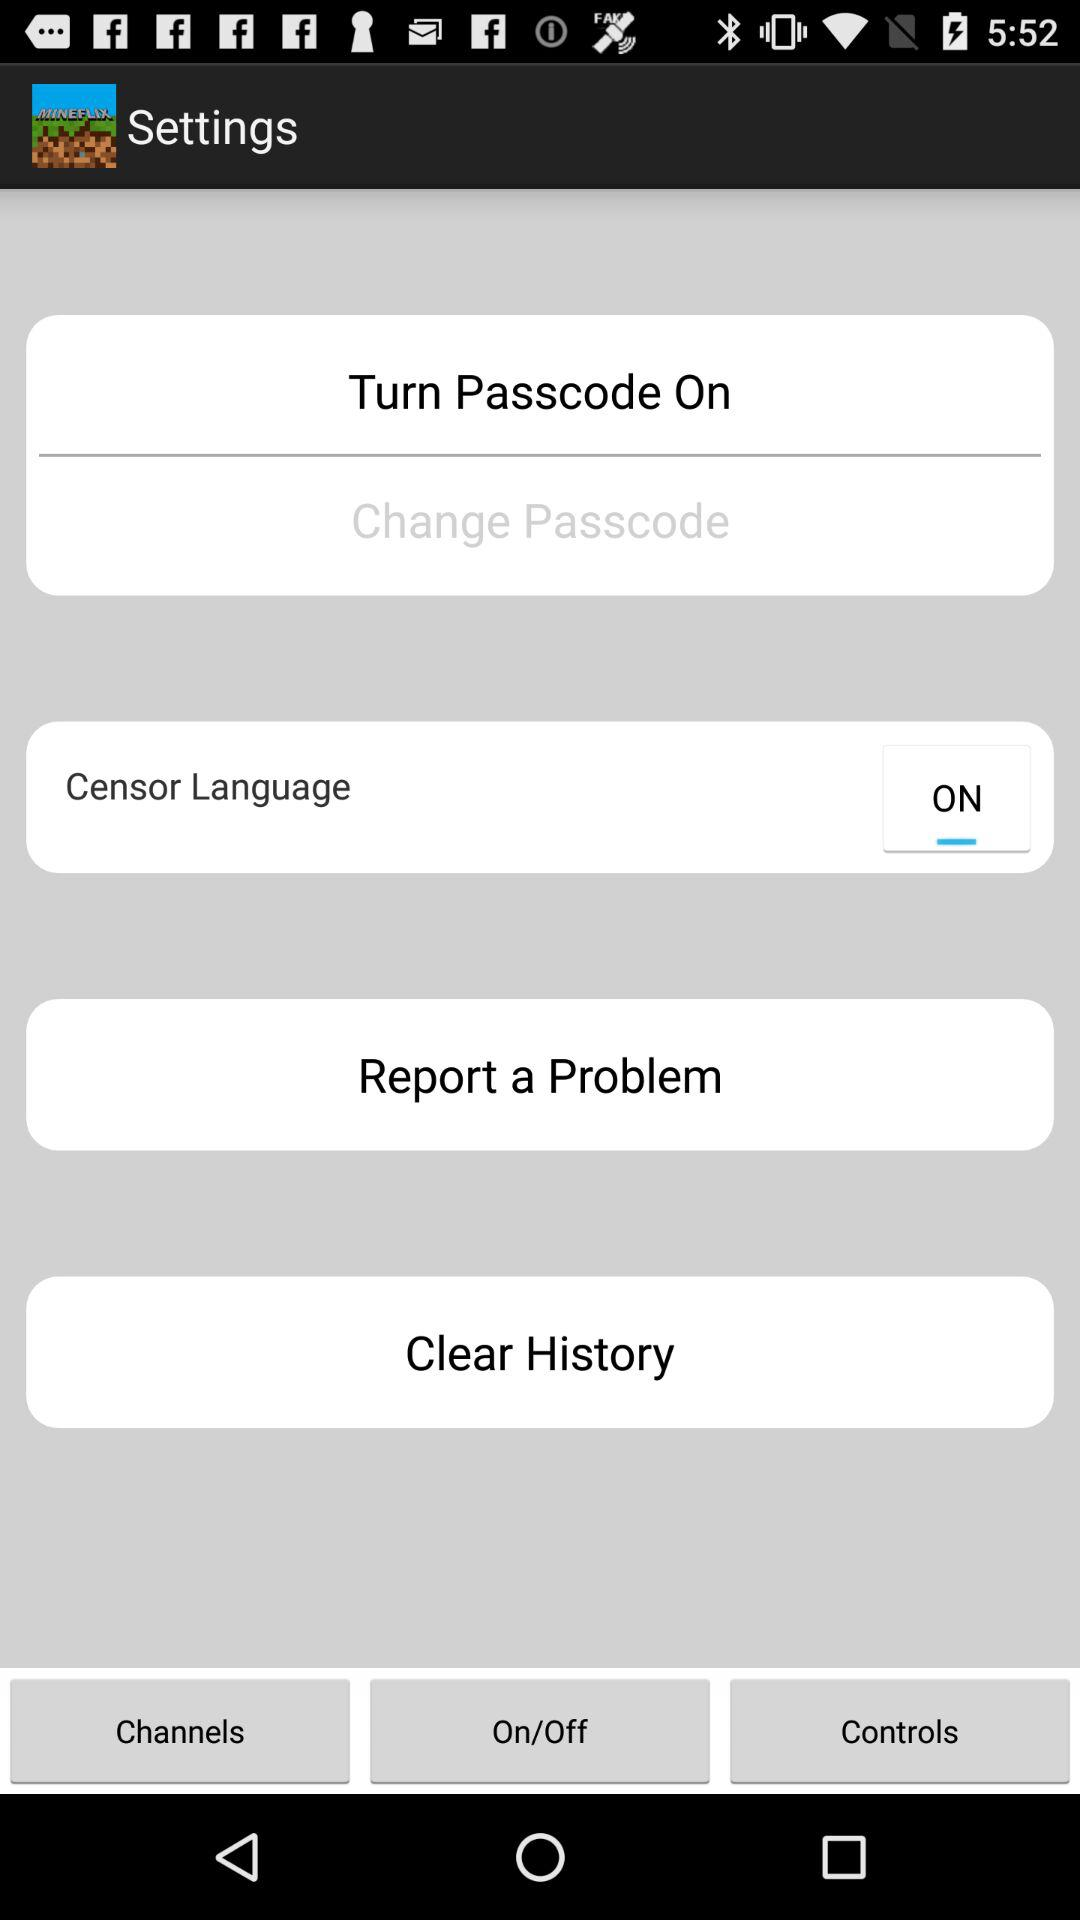What is the status of "Turn Passcode"? "Turn Passcode" is turned on. 